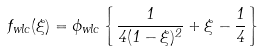Convert formula to latex. <formula><loc_0><loc_0><loc_500><loc_500>f _ { w l c } ( \xi ) = \phi _ { w l c } \left \{ \frac { 1 } { 4 ( 1 - \xi ) ^ { 2 } } + \xi - \frac { 1 } { 4 } \right \}</formula> 